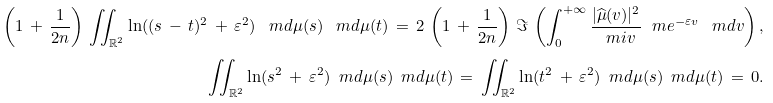Convert formula to latex. <formula><loc_0><loc_0><loc_500><loc_500>\left ( 1 \, + \, \frac { 1 } { 2 n } \right ) \, \iint _ { \mathbb { R } ^ { 2 } } \ln ( ( s \, - \, t ) ^ { 2 } \, + \, \varepsilon ^ { 2 } ) \, \ m d \mu ( s ) \, \ m d \mu ( t ) \, = \, 2 \, \left ( 1 \, + \, \frac { 1 } { 2 n } \right ) \, \Im \, \left ( \int _ { 0 } ^ { + \infty } \frac { | \widehat { \mu } ( v ) | ^ { 2 } } { \ m i v } \ m e ^ { - \varepsilon v } \, \ m d v \right ) , \\ \iint _ { \mathbb { R } ^ { 2 } } \ln ( s ^ { 2 } \, + \, \varepsilon ^ { 2 } ) \, \ m d \mu ( s ) \, \ m d \mu ( t ) \, = \, \iint _ { \mathbb { R } ^ { 2 } } \ln ( t ^ { 2 } \, + \, \varepsilon ^ { 2 } ) \, \ m d \mu ( s ) \, \ m d \mu ( t ) \, = \, 0 .</formula> 